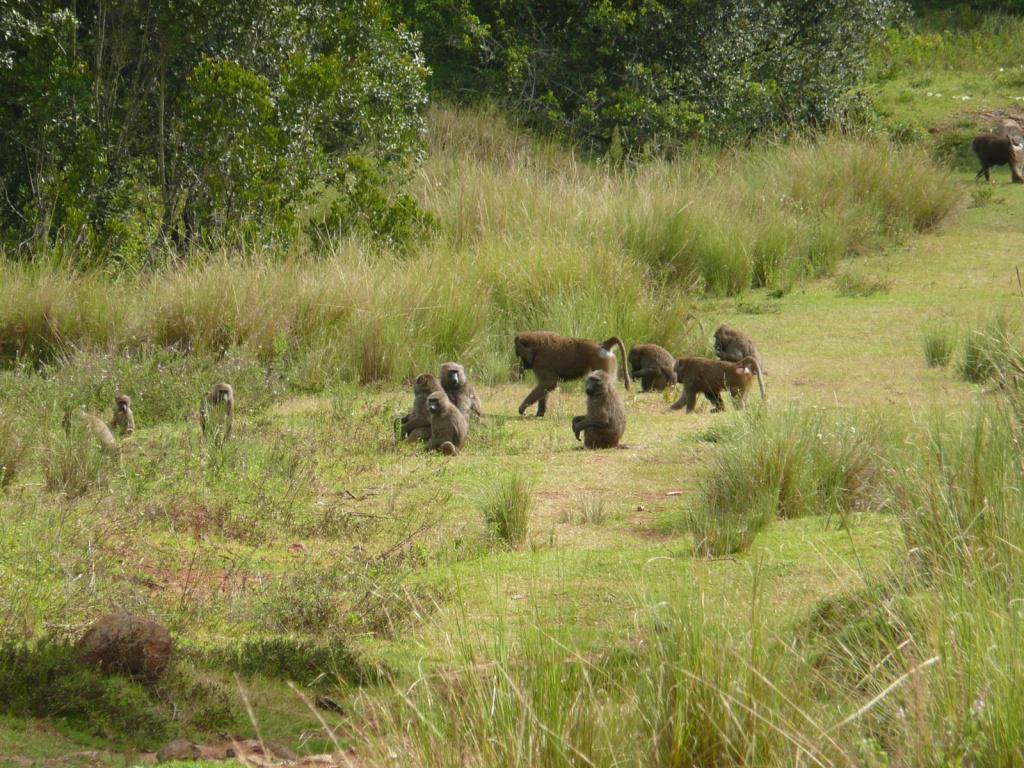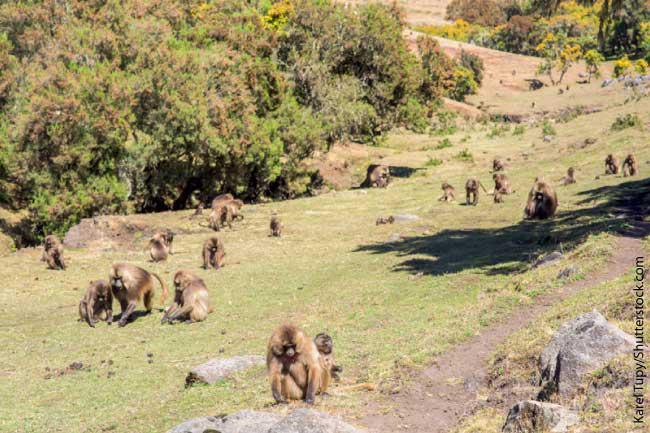The first image is the image on the left, the second image is the image on the right. Evaluate the accuracy of this statement regarding the images: "Several primates are situated on a dirt roadway.". Is it true? Answer yes or no. No. The first image is the image on the left, the second image is the image on the right. For the images shown, is this caption "An image shows baboons on a dirt path flanked by greenery." true? Answer yes or no. No. 